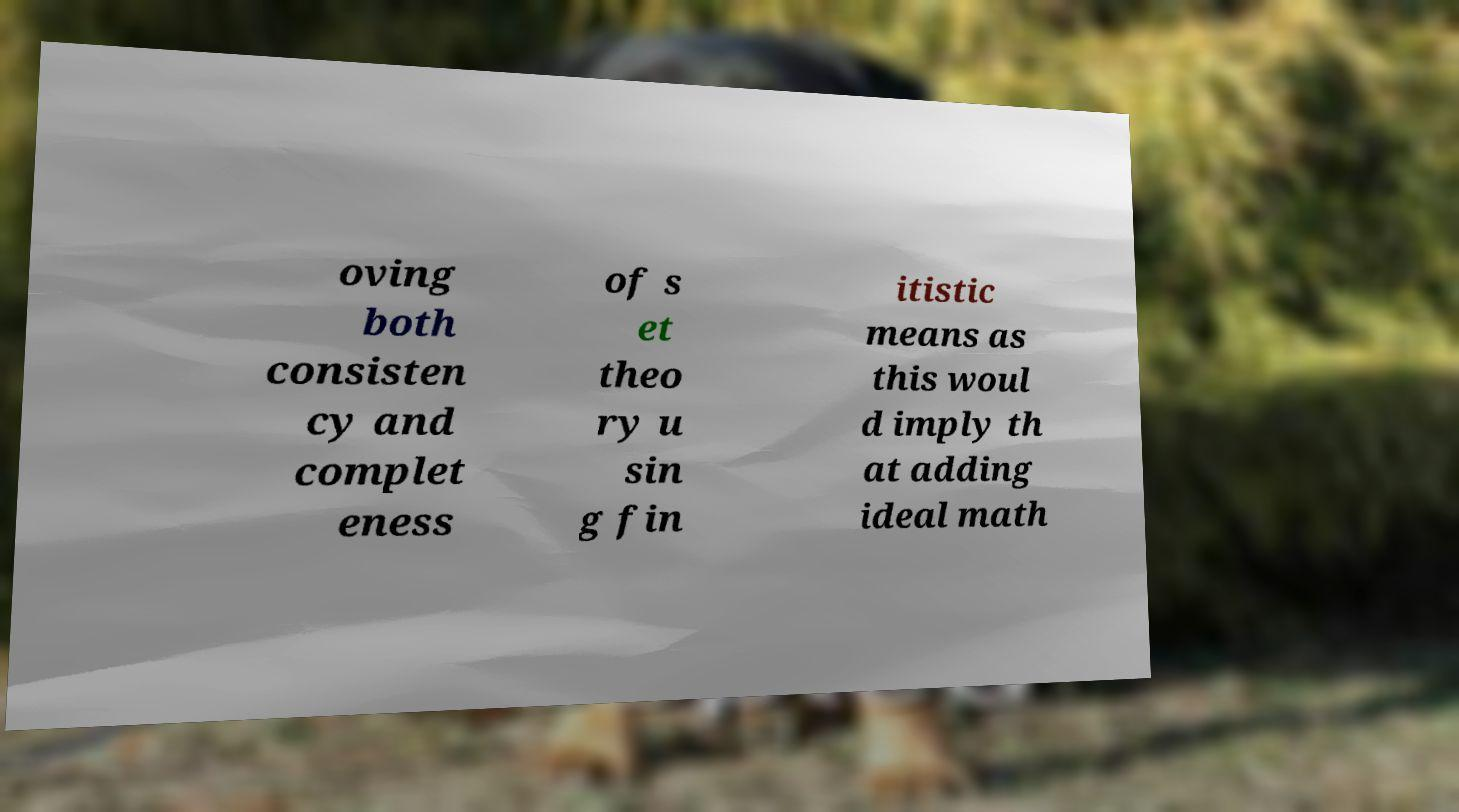There's text embedded in this image that I need extracted. Can you transcribe it verbatim? oving both consisten cy and complet eness of s et theo ry u sin g fin itistic means as this woul d imply th at adding ideal math 